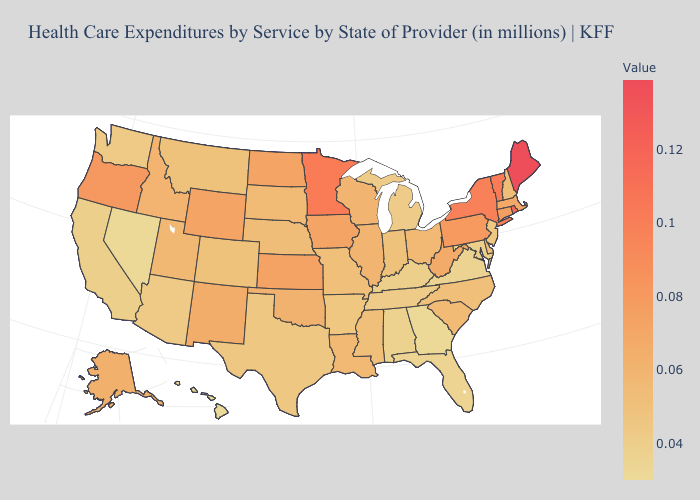Which states have the lowest value in the MidWest?
Concise answer only. Michigan. Among the states that border Kansas , which have the lowest value?
Quick response, please. Colorado. Which states have the lowest value in the USA?
Quick response, please. Hawaii. Which states have the highest value in the USA?
Short answer required. Maine. Does Minnesota have a higher value than Rhode Island?
Answer briefly. No. Does Connecticut have a lower value than California?
Concise answer only. No. Does Kansas have the highest value in the MidWest?
Be succinct. No. 